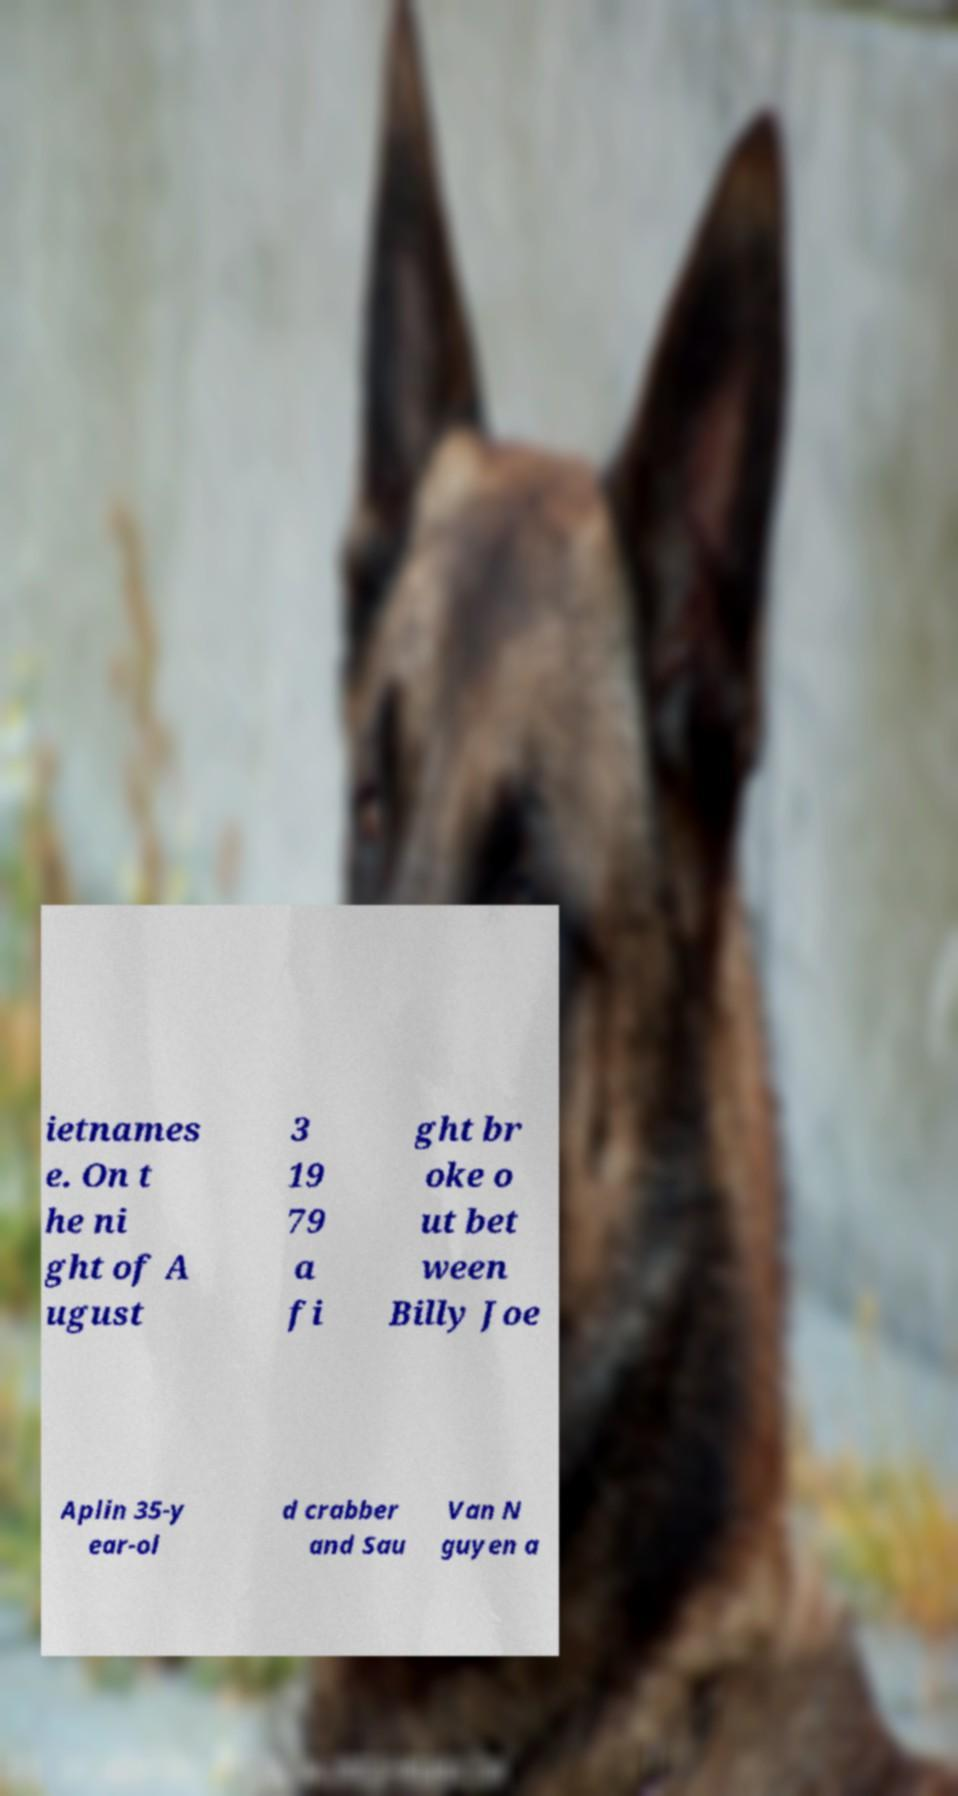I need the written content from this picture converted into text. Can you do that? ietnames e. On t he ni ght of A ugust 3 19 79 a fi ght br oke o ut bet ween Billy Joe Aplin 35-y ear-ol d crabber and Sau Van N guyen a 